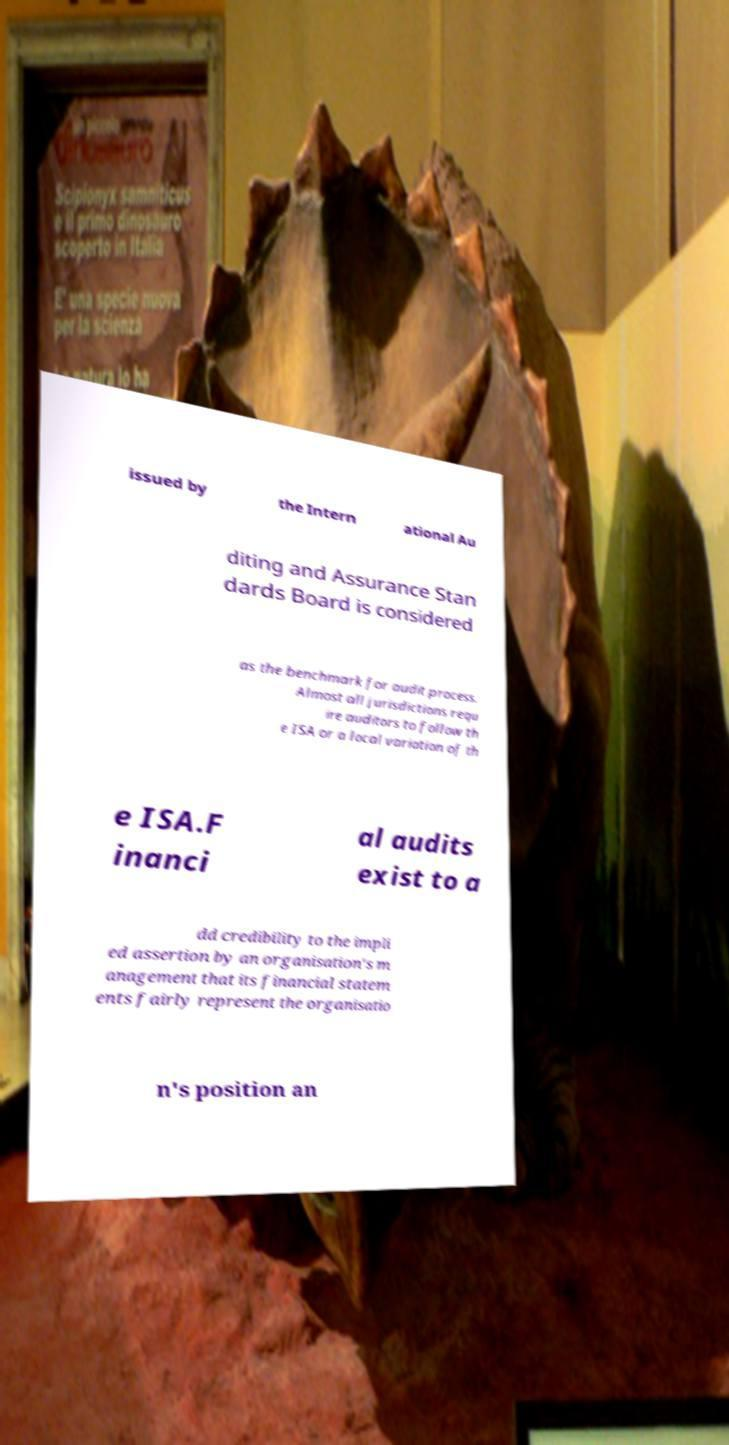Please read and relay the text visible in this image. What does it say? issued by the Intern ational Au diting and Assurance Stan dards Board is considered as the benchmark for audit process. Almost all jurisdictions requ ire auditors to follow th e ISA or a local variation of th e ISA.F inanci al audits exist to a dd credibility to the impli ed assertion by an organisation's m anagement that its financial statem ents fairly represent the organisatio n's position an 